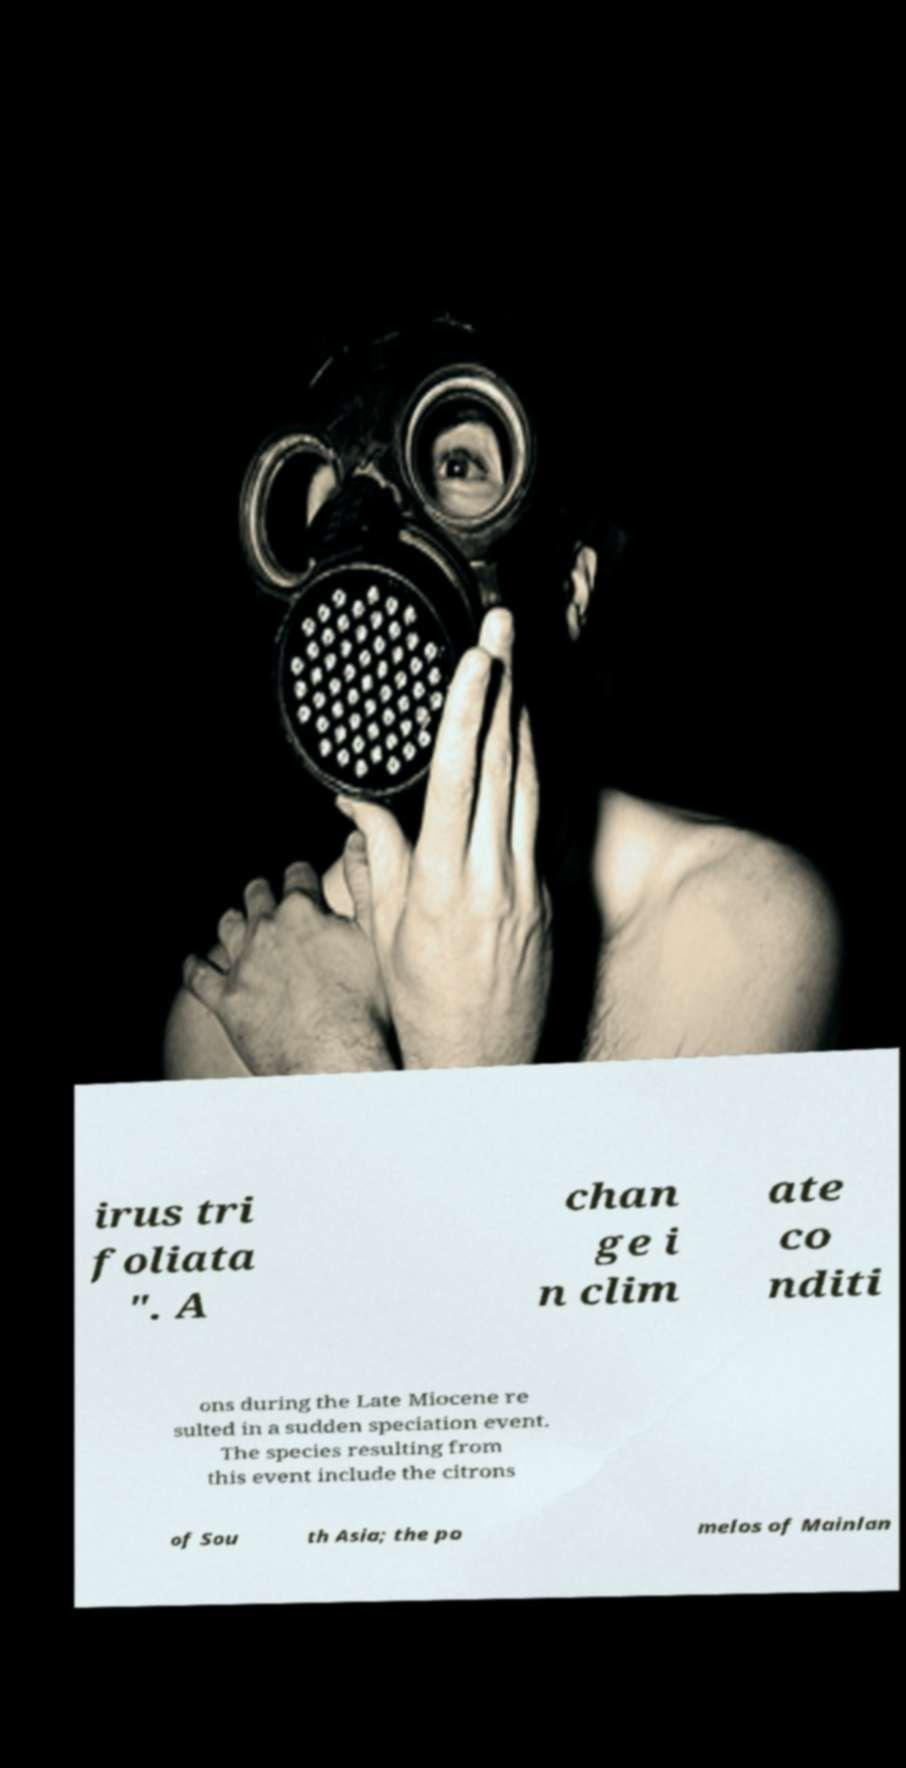Please identify and transcribe the text found in this image. irus tri foliata ". A chan ge i n clim ate co nditi ons during the Late Miocene re sulted in a sudden speciation event. The species resulting from this event include the citrons of Sou th Asia; the po melos of Mainlan 